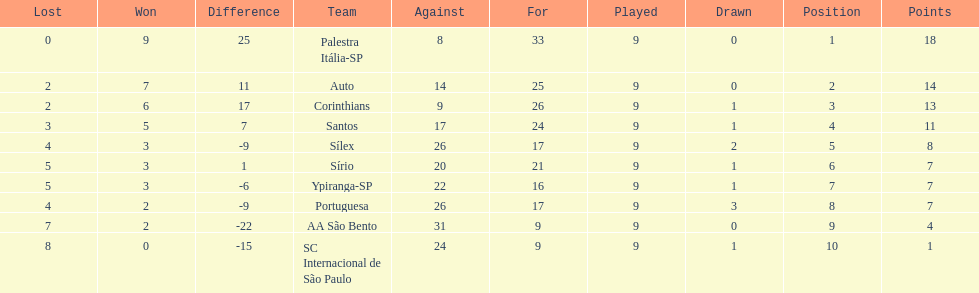How many points did the brazilian football team auto get in 1926? 14. 